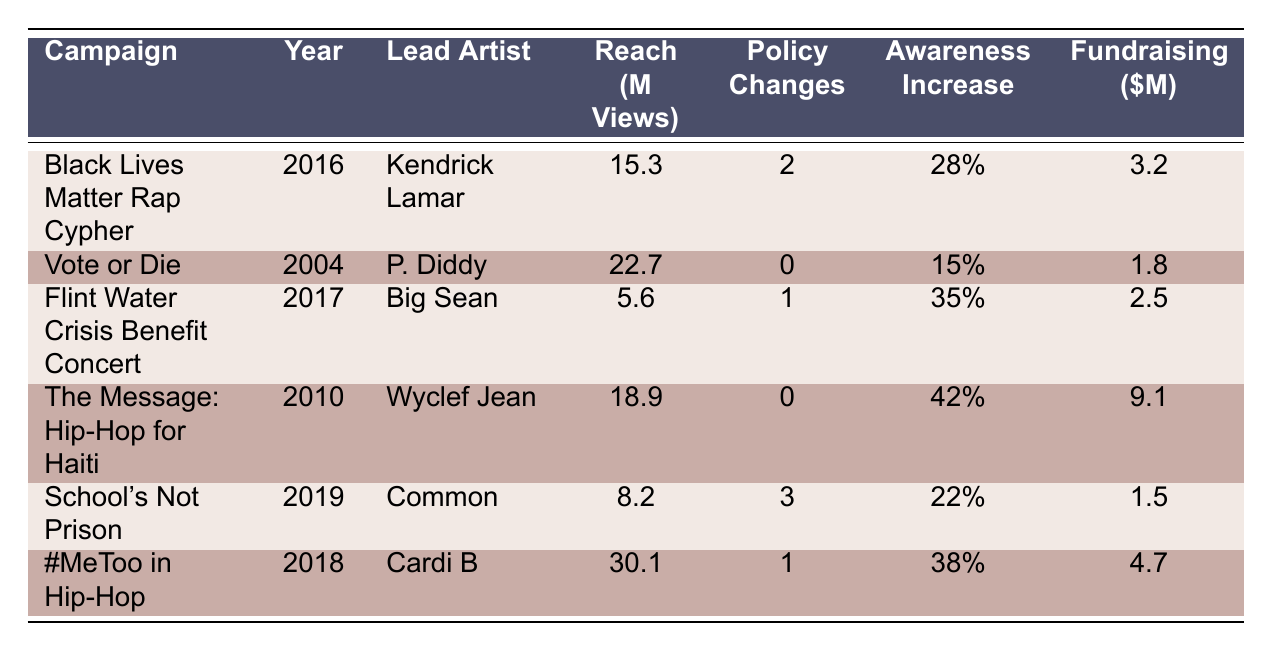What is the social issue addressed by the "Vote or Die" campaign? The "Vote or Die" campaign addresses the social issue of voter turnout. This information can be located in the "Social Issue" column for the corresponding campaign row.
Answer: Voter Turnout Which campaign had the highest reach in million views? The campaign with the highest reach in million views is "#MeToo in Hip-Hop" with 30.1 million views. This can be determined by comparing the "Reach (Million Views)" values for each campaign.
Answer: #MeToo in Hip-Hop What is the total amount of fundraising generated by the campaigns addressing police brutality and education reform? The campaigns addressing police brutality ("Black Lives Matter Rap Cypher") and education reform ("School's Not Prison") have fundraising values of 3.2 million and 1.5 million, respectively. Adding these together gives: 3.2 + 1.5 = 4.7 million.
Answer: 4.7 million Did any of the campaigns result in no policy changes? If so, name one. Yes, both the "Vote or Die" campaign and "The Message: Hip-Hop for Haiti" campaign resulted in no policy changes. This is evident from the "Policy Changes" column where both campaigns have a value of 0.
Answer: Yes, "Vote or Die" What was the average public awareness increase percentage for all the campaigns listed? To calculate the average public awareness increase percentage, add all the percentages: 28 + 15 + 35 + 42 + 22 + 38 = 180. There are 6 campaigns, so divide by 6: 180 / 6 = 30%.
Answer: 30% 